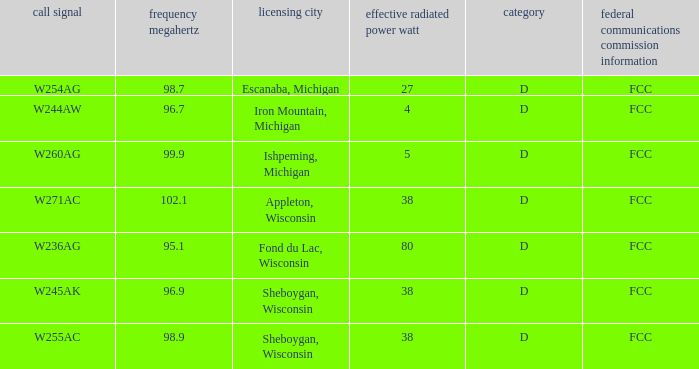What was the ERP W for 96.7 MHz? 4.0. 